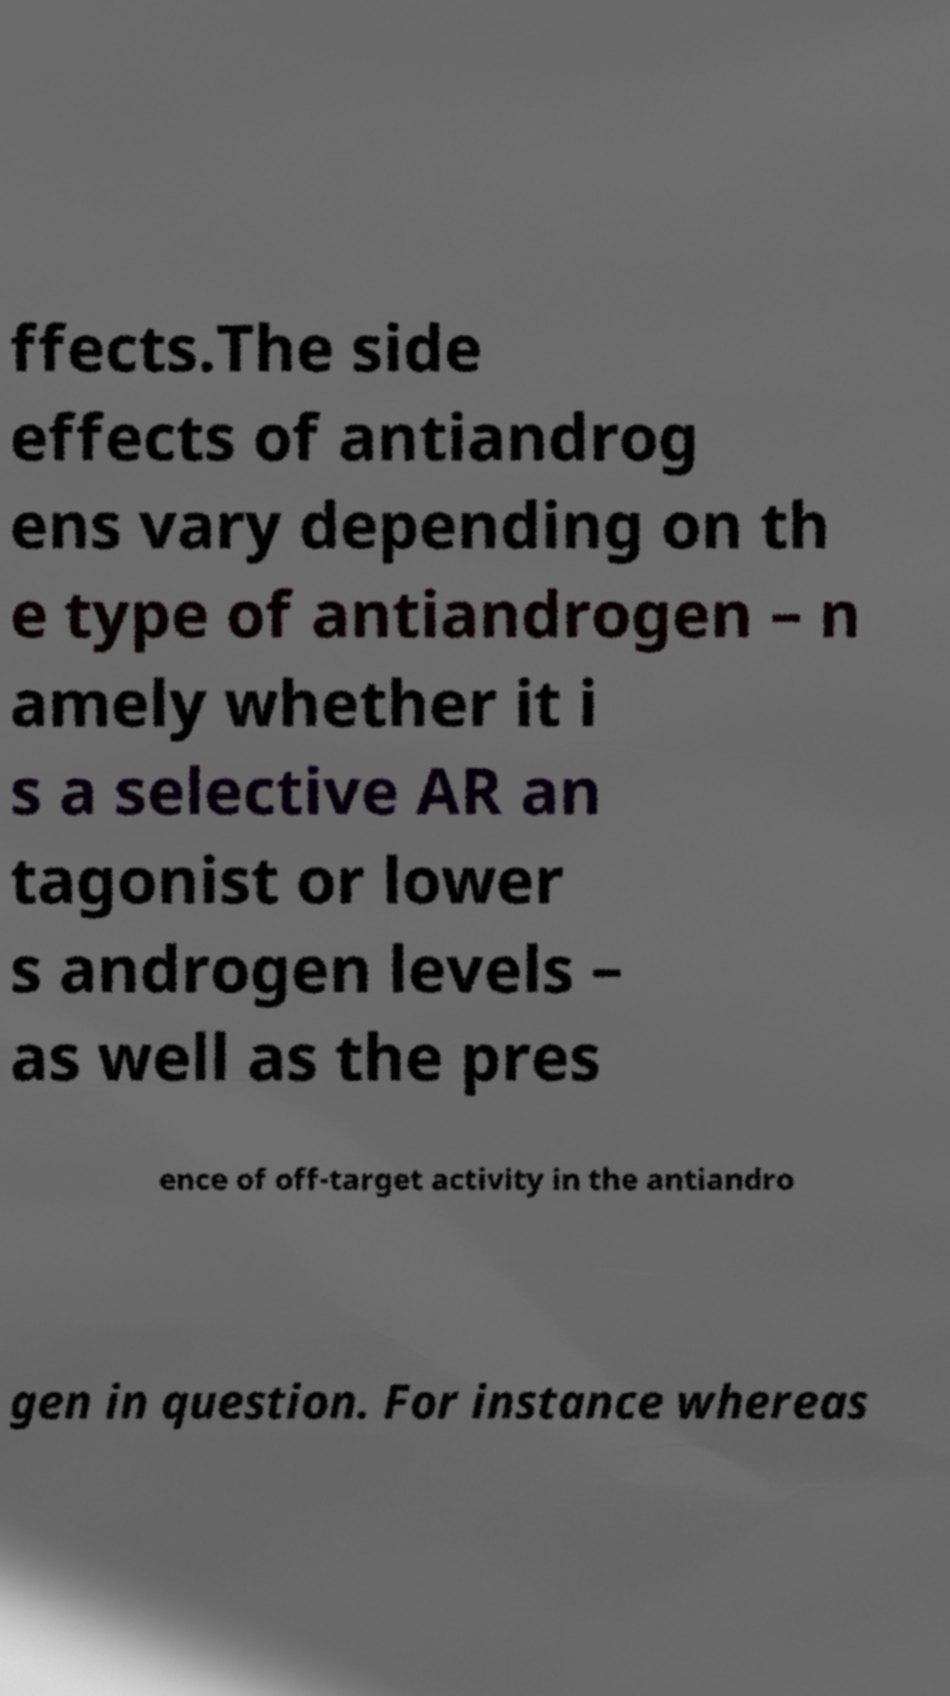There's text embedded in this image that I need extracted. Can you transcribe it verbatim? ffects.The side effects of antiandrog ens vary depending on th e type of antiandrogen – n amely whether it i s a selective AR an tagonist or lower s androgen levels – as well as the pres ence of off-target activity in the antiandro gen in question. For instance whereas 